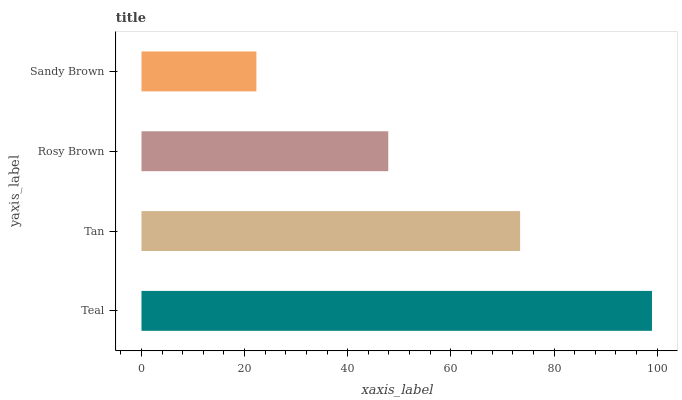Is Sandy Brown the minimum?
Answer yes or no. Yes. Is Teal the maximum?
Answer yes or no. Yes. Is Tan the minimum?
Answer yes or no. No. Is Tan the maximum?
Answer yes or no. No. Is Teal greater than Tan?
Answer yes or no. Yes. Is Tan less than Teal?
Answer yes or no. Yes. Is Tan greater than Teal?
Answer yes or no. No. Is Teal less than Tan?
Answer yes or no. No. Is Tan the high median?
Answer yes or no. Yes. Is Rosy Brown the low median?
Answer yes or no. Yes. Is Sandy Brown the high median?
Answer yes or no. No. Is Sandy Brown the low median?
Answer yes or no. No. 